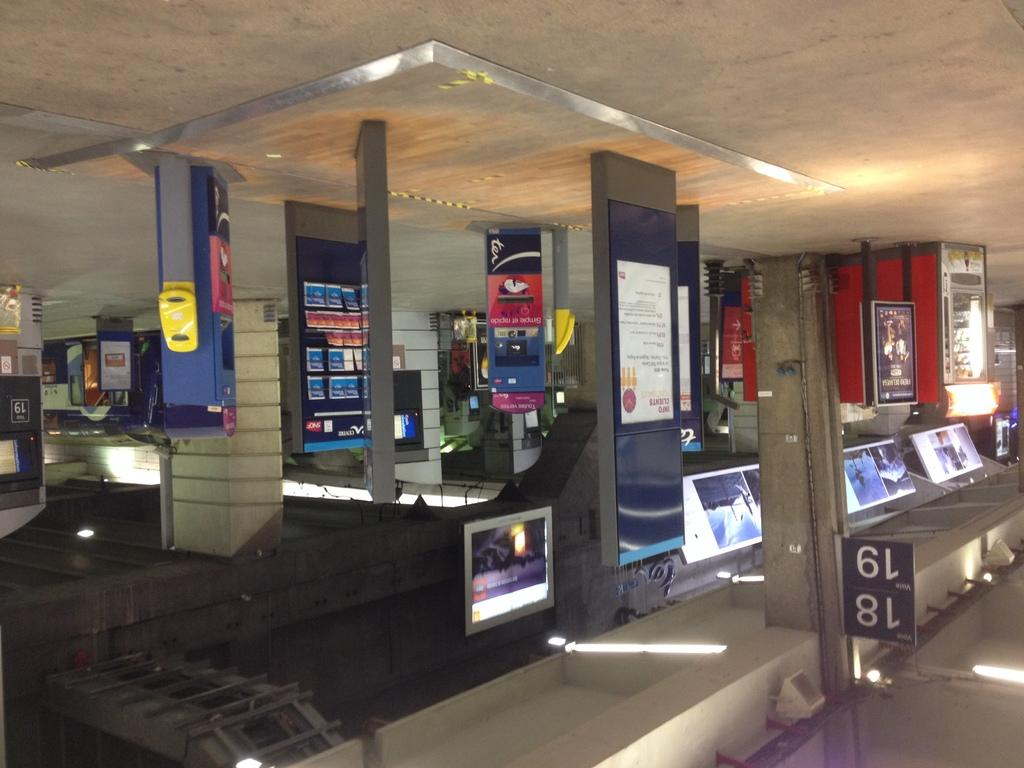What objects are located in the center of the image? There are boards, televisions, chairs, and lights in the center of the image. What is the orientation of the image? The top of the image represents the floor, and the bottom of the image represents the ceiling. Are there any lights on the ceiling? Yes, there are lights on the ceiling. What type of cheese is being raked by the tooth in the image? There is no cheese, tooth, or rake present in the image. 